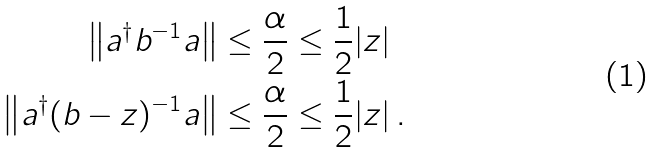Convert formula to latex. <formula><loc_0><loc_0><loc_500><loc_500>\left \| a ^ { \dagger } b ^ { - 1 } a \right \| & \leq \frac { \alpha } { 2 } \leq \frac { 1 } { 2 } | z | \\ \left \| a ^ { \dagger } ( b - z ) ^ { - 1 } a \right \| & \leq \frac { \alpha } { 2 } \leq \frac { 1 } { 2 } | z | \, .</formula> 